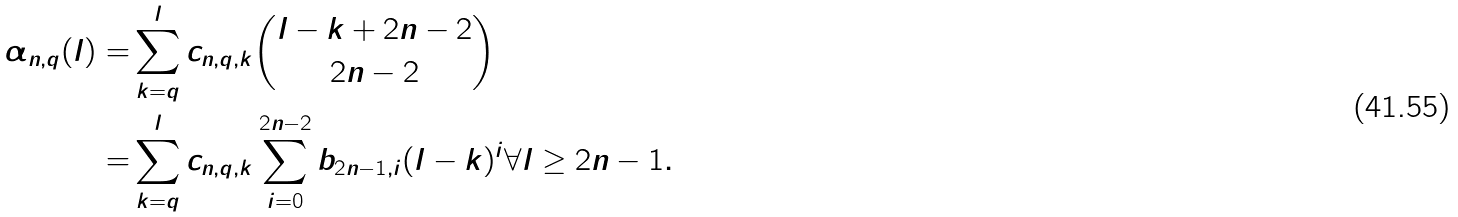<formula> <loc_0><loc_0><loc_500><loc_500>\alpha _ { n , q } ( l ) = & \sum _ { k = q } ^ { l } c _ { n , q , k } \binom { l - k + 2 n - 2 } { 2 n - 2 } \\ = & \sum _ { k = q } ^ { l } c _ { n , q , k } \sum _ { i = 0 } ^ { 2 n - 2 } b _ { 2 n - 1 , i } ( l - k ) ^ { i } \forall l \geq 2 n - 1 .</formula> 